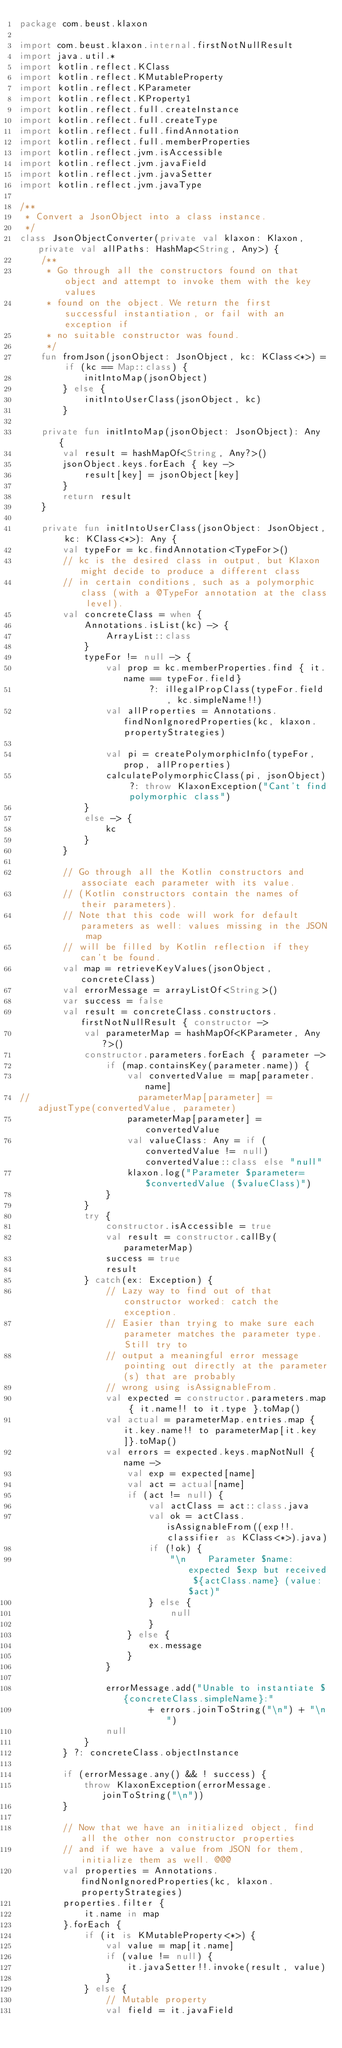Convert code to text. <code><loc_0><loc_0><loc_500><loc_500><_Kotlin_>package com.beust.klaxon

import com.beust.klaxon.internal.firstNotNullResult
import java.util.*
import kotlin.reflect.KClass
import kotlin.reflect.KMutableProperty
import kotlin.reflect.KParameter
import kotlin.reflect.KProperty1
import kotlin.reflect.full.createInstance
import kotlin.reflect.full.createType
import kotlin.reflect.full.findAnnotation
import kotlin.reflect.full.memberProperties
import kotlin.reflect.jvm.isAccessible
import kotlin.reflect.jvm.javaField
import kotlin.reflect.jvm.javaSetter
import kotlin.reflect.jvm.javaType

/**
 * Convert a JsonObject into a class instance.
 */
class JsonObjectConverter(private val klaxon: Klaxon, private val allPaths: HashMap<String, Any>) {
    /**
     * Go through all the constructors found on that object and attempt to invoke them with the key values
     * found on the object. We return the first successful instantiation, or fail with an exception if
     * no suitable constructor was found.
     */
    fun fromJson(jsonObject: JsonObject, kc: KClass<*>) = if (kc == Map::class) {
            initIntoMap(jsonObject)
        } else {
            initIntoUserClass(jsonObject, kc)
        }

    private fun initIntoMap(jsonObject: JsonObject): Any {
        val result = hashMapOf<String, Any?>()
        jsonObject.keys.forEach { key ->
            result[key] = jsonObject[key]
        }
        return result
    }

    private fun initIntoUserClass(jsonObject: JsonObject, kc: KClass<*>): Any {
        val typeFor = kc.findAnnotation<TypeFor>()
        // kc is the desired class in output, but Klaxon might decide to produce a different class
        // in certain conditions, such as a polymorphic class (with a @TypeFor annotation at the class level).
        val concreteClass = when {
            Annotations.isList(kc) -> {
                ArrayList::class
            }
            typeFor != null -> {
                val prop = kc.memberProperties.find { it.name == typeFor.field}
                        ?: illegalPropClass(typeFor.field, kc.simpleName!!)
                val allProperties = Annotations.findNonIgnoredProperties(kc, klaxon.propertyStrategies)

                val pi = createPolymorphicInfo(typeFor, prop, allProperties)
                calculatePolymorphicClass(pi, jsonObject) ?: throw KlaxonException("Cant't find polymorphic class")
            }
            else -> {
                kc
            }
        }

        // Go through all the Kotlin constructors and associate each parameter with its value.
        // (Kotlin constructors contain the names of their parameters).
        // Note that this code will work for default parameters as well: values missing in the JSON map
        // will be filled by Kotlin reflection if they can't be found.
        val map = retrieveKeyValues(jsonObject, concreteClass)
        val errorMessage = arrayListOf<String>()
        var success = false
        val result = concreteClass.constructors.firstNotNullResult { constructor ->
            val parameterMap = hashMapOf<KParameter, Any?>()
            constructor.parameters.forEach { parameter ->
                if (map.containsKey(parameter.name)) {
                    val convertedValue = map[parameter.name]
//                    parameterMap[parameter] = adjustType(convertedValue, parameter)
                    parameterMap[parameter] = convertedValue
                    val valueClass: Any = if (convertedValue != null) convertedValue::class else "null"
                    klaxon.log("Parameter $parameter=$convertedValue ($valueClass)")
                }
            }
            try {
                constructor.isAccessible = true
                val result = constructor.callBy(parameterMap)
                success = true
                result
            } catch(ex: Exception) {
                // Lazy way to find out of that constructor worked: catch the exception.
                // Easier than trying to make sure each parameter matches the parameter type. Still try to
                // output a meaningful error message pointing out directly at the parameter(s) that are probably
                // wrong using isAssignableFrom.
                val expected = constructor.parameters.map { it.name!! to it.type }.toMap()
                val actual = parameterMap.entries.map { it.key.name!! to parameterMap[it.key]}.toMap()
                val errors = expected.keys.mapNotNull { name ->
                    val exp = expected[name]
                    val act = actual[name]
                    if (act != null) {
                        val actClass = act::class.java
                        val ok = actClass.isAssignableFrom((exp!!.classifier as KClass<*>).java)
                        if (!ok) {
                            "\n    Parameter $name: expected $exp but received ${actClass.name} (value: $act)"
                        } else {
                            null
                        }
                    } else {
                        ex.message
                    }
                }

                errorMessage.add("Unable to instantiate ${concreteClass.simpleName}:"
                        + errors.joinToString("\n") + "\n")
                null
            }
        } ?: concreteClass.objectInstance

        if (errorMessage.any() && ! success) {
            throw KlaxonException(errorMessage.joinToString("\n"))
        }

        // Now that we have an initialized object, find all the other non constructor properties
        // and if we have a value from JSON for them, initialize them as well. @@@
        val properties = Annotations.findNonIgnoredProperties(kc, klaxon.propertyStrategies)
        properties.filter {
            it.name in map
        }.forEach {
            if (it is KMutableProperty<*>) {
                val value = map[it.name]
                if (value != null) {
                    it.javaSetter!!.invoke(result, value)
                }
            } else {
                // Mutable property
                val field = it.javaField</code> 